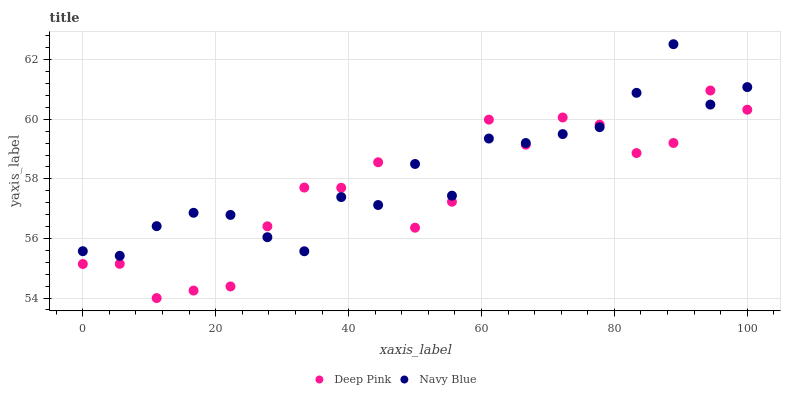Does Deep Pink have the minimum area under the curve?
Answer yes or no. Yes. Does Navy Blue have the maximum area under the curve?
Answer yes or no. Yes. Does Deep Pink have the maximum area under the curve?
Answer yes or no. No. Is Navy Blue the smoothest?
Answer yes or no. Yes. Is Deep Pink the roughest?
Answer yes or no. Yes. Is Deep Pink the smoothest?
Answer yes or no. No. Does Deep Pink have the lowest value?
Answer yes or no. Yes. Does Navy Blue have the highest value?
Answer yes or no. Yes. Does Deep Pink have the highest value?
Answer yes or no. No. Does Navy Blue intersect Deep Pink?
Answer yes or no. Yes. Is Navy Blue less than Deep Pink?
Answer yes or no. No. Is Navy Blue greater than Deep Pink?
Answer yes or no. No. 